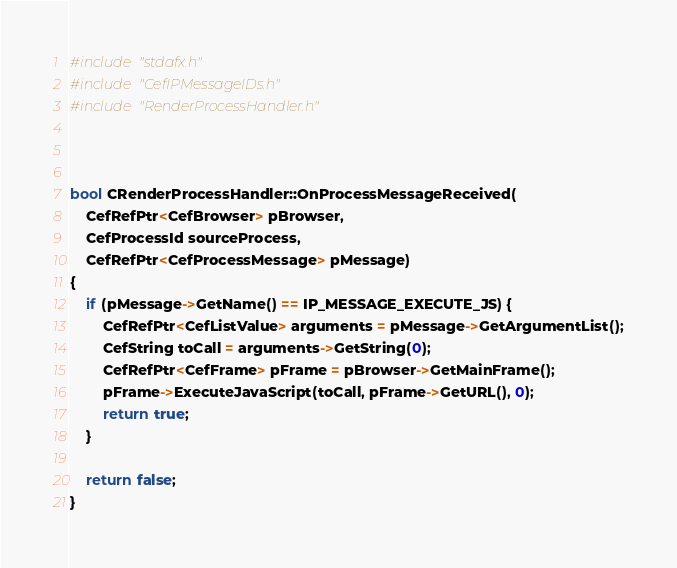<code> <loc_0><loc_0><loc_500><loc_500><_C++_>#include "stdafx.h"
#include "CefIPMessageIDs.h"
#include "RenderProcessHandler.h"



bool CRenderProcessHandler::OnProcessMessageReceived(
    CefRefPtr<CefBrowser> pBrowser, 
    CefProcessId sourceProcess, 
    CefRefPtr<CefProcessMessage> pMessage)
{
    if (pMessage->GetName() == IP_MESSAGE_EXECUTE_JS) {
        CefRefPtr<CefListValue> arguments = pMessage->GetArgumentList();
        CefString toCall = arguments->GetString(0);
        CefRefPtr<CefFrame> pFrame = pBrowser->GetMainFrame();
        pFrame->ExecuteJavaScript(toCall, pFrame->GetURL(), 0);
        return true;
    }

    return false;
}
</code> 